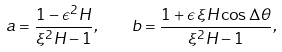Convert formula to latex. <formula><loc_0><loc_0><loc_500><loc_500>a = \frac { 1 - \epsilon ^ { 2 } H } { \xi ^ { 2 } H - 1 } , \quad b = \frac { 1 + \epsilon \, \xi H \cos \Delta \theta } { \xi ^ { 2 } H - 1 } ,</formula> 